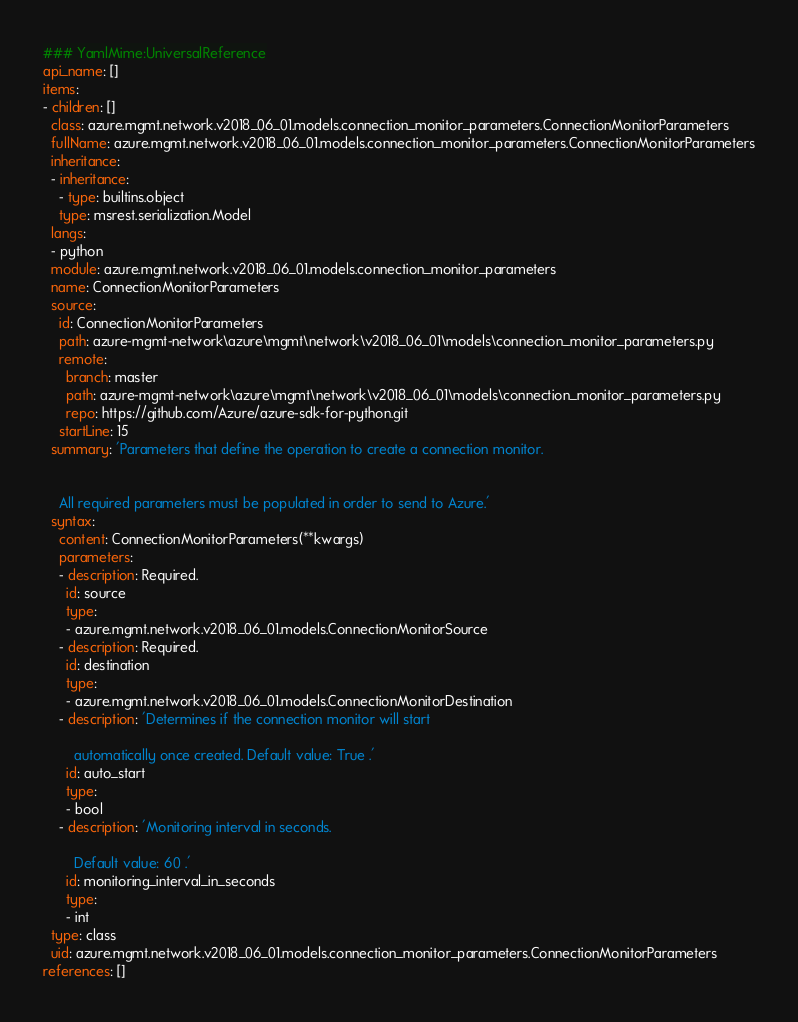Convert code to text. <code><loc_0><loc_0><loc_500><loc_500><_YAML_>### YamlMime:UniversalReference
api_name: []
items:
- children: []
  class: azure.mgmt.network.v2018_06_01.models.connection_monitor_parameters.ConnectionMonitorParameters
  fullName: azure.mgmt.network.v2018_06_01.models.connection_monitor_parameters.ConnectionMonitorParameters
  inheritance:
  - inheritance:
    - type: builtins.object
    type: msrest.serialization.Model
  langs:
  - python
  module: azure.mgmt.network.v2018_06_01.models.connection_monitor_parameters
  name: ConnectionMonitorParameters
  source:
    id: ConnectionMonitorParameters
    path: azure-mgmt-network\azure\mgmt\network\v2018_06_01\models\connection_monitor_parameters.py
    remote:
      branch: master
      path: azure-mgmt-network\azure\mgmt\network\v2018_06_01\models\connection_monitor_parameters.py
      repo: https://github.com/Azure/azure-sdk-for-python.git
    startLine: 15
  summary: 'Parameters that define the operation to create a connection monitor.


    All required parameters must be populated in order to send to Azure.'
  syntax:
    content: ConnectionMonitorParameters(**kwargs)
    parameters:
    - description: Required.
      id: source
      type:
      - azure.mgmt.network.v2018_06_01.models.ConnectionMonitorSource
    - description: Required.
      id: destination
      type:
      - azure.mgmt.network.v2018_06_01.models.ConnectionMonitorDestination
    - description: 'Determines if the connection monitor will start

        automatically once created. Default value: True .'
      id: auto_start
      type:
      - bool
    - description: 'Monitoring interval in seconds.

        Default value: 60 .'
      id: monitoring_interval_in_seconds
      type:
      - int
  type: class
  uid: azure.mgmt.network.v2018_06_01.models.connection_monitor_parameters.ConnectionMonitorParameters
references: []
</code> 